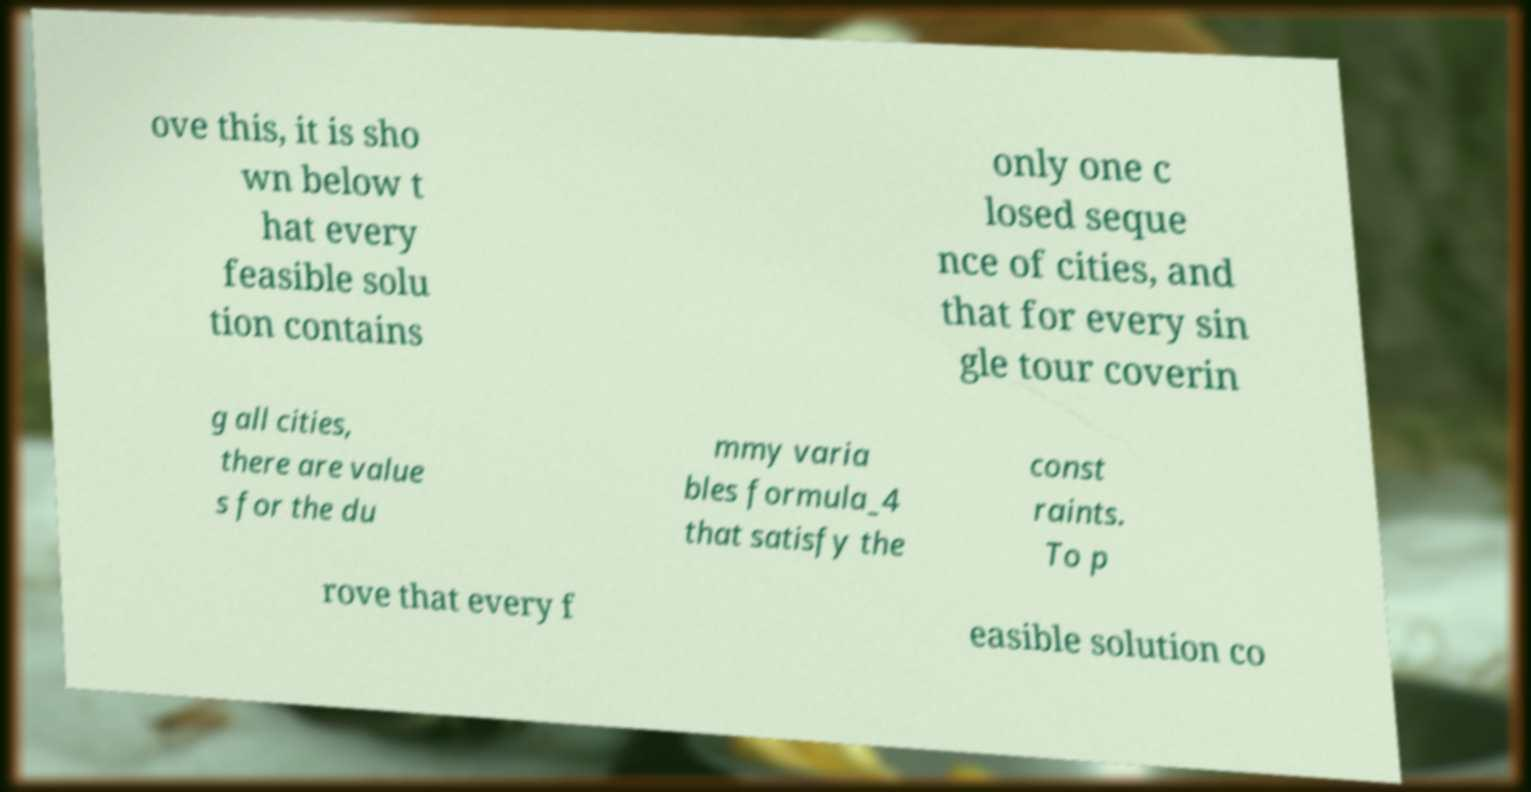There's text embedded in this image that I need extracted. Can you transcribe it verbatim? ove this, it is sho wn below t hat every feasible solu tion contains only one c losed seque nce of cities, and that for every sin gle tour coverin g all cities, there are value s for the du mmy varia bles formula_4 that satisfy the const raints. To p rove that every f easible solution co 